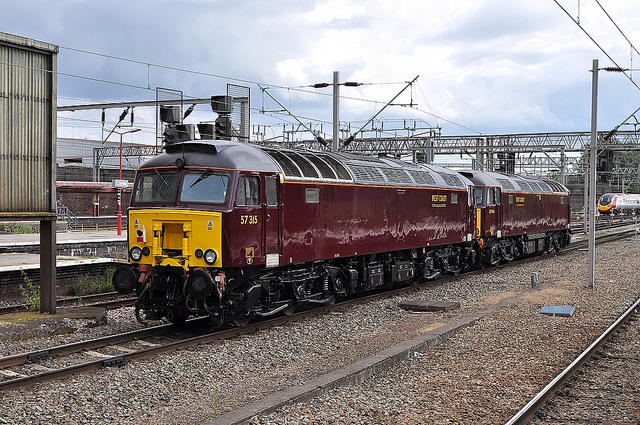Identify the text contained in this image. 57315 